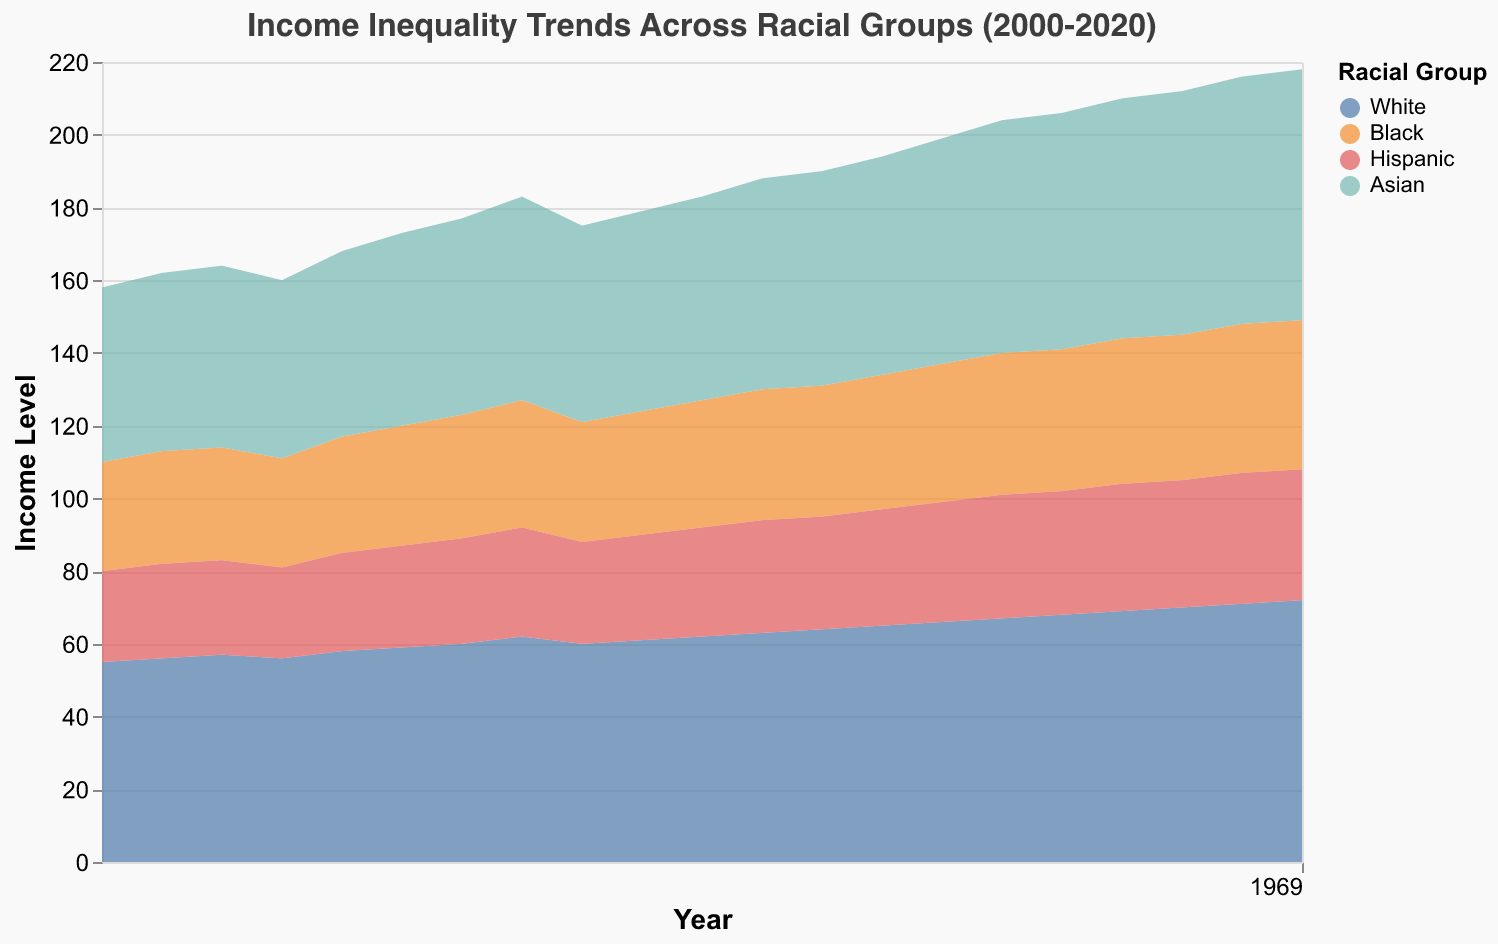What is the title of the chart? The title is positioned at the top center of the chart and is easily readable.
Answer: Income Inequality Trends Across Racial Groups (2000-2020) How many racial groups are represented in the chart? Observing the legend, we see that the chart includes four distinct racial groups.
Answer: Four Which racial group shows the highest income level in 2020? By looking at the chart and observing the values for each group in 2020, the highest value is for White.
Answer: White What is the income level for Hispanic individuals in the year 2010? By tracing the Hispanic area to the year 2010 on the X-axis, we see that the income level is 30.
Answer: 30 By how much has the income level of Black individuals increased from 2000 to 2020? The income level for Black individuals in 2000 is 30, and in 2020 it is 41. The increase is computed by subtracting the 2000 figure from the 2020 figure.
Answer: 11 Which two racial groups have a very similar income level trend between 2008 and 2014? Observing the overlapping areas on the chart, it is evident that the income levels for Black and Hispanic individuals have very similar trajectories during this period.
Answer: Black and Hispanic What is the range of income levels for Asian individuals over the 20-year period? From the chart, the lowest income level for Asians is 48 in 2000, and the highest is 69 in 2020. Subtracting the minimum from the maximum gives the range.
Answer: 21 Which racial group experienced the most significant increase in income level between 2000 and 2020? By comparing the difference in income levels from 2000 to 2020 for all groups, Asians show the highest difference (69 in 2020 - 48 in 2000 = 21).
Answer: Asian Compare the income level trends of White and Hispanic groups. Which group had a more consistent increase over the years? By examining the chart, the White group has a more consistent increase without significant dips, whereas the Hispanic group's trend shows fluctuations.
Answer: White What year did the income level for Hispanic individuals reach 35? By observing the area chart, Hispanic income level reaches 35 in the year 2017.
Answer: 2017 